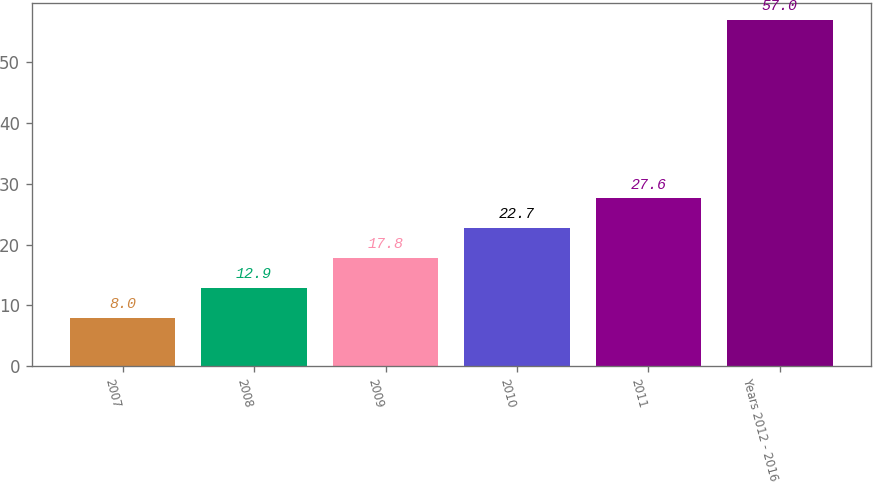Convert chart. <chart><loc_0><loc_0><loc_500><loc_500><bar_chart><fcel>2007<fcel>2008<fcel>2009<fcel>2010<fcel>2011<fcel>Years 2012 - 2016<nl><fcel>8<fcel>12.9<fcel>17.8<fcel>22.7<fcel>27.6<fcel>57<nl></chart> 